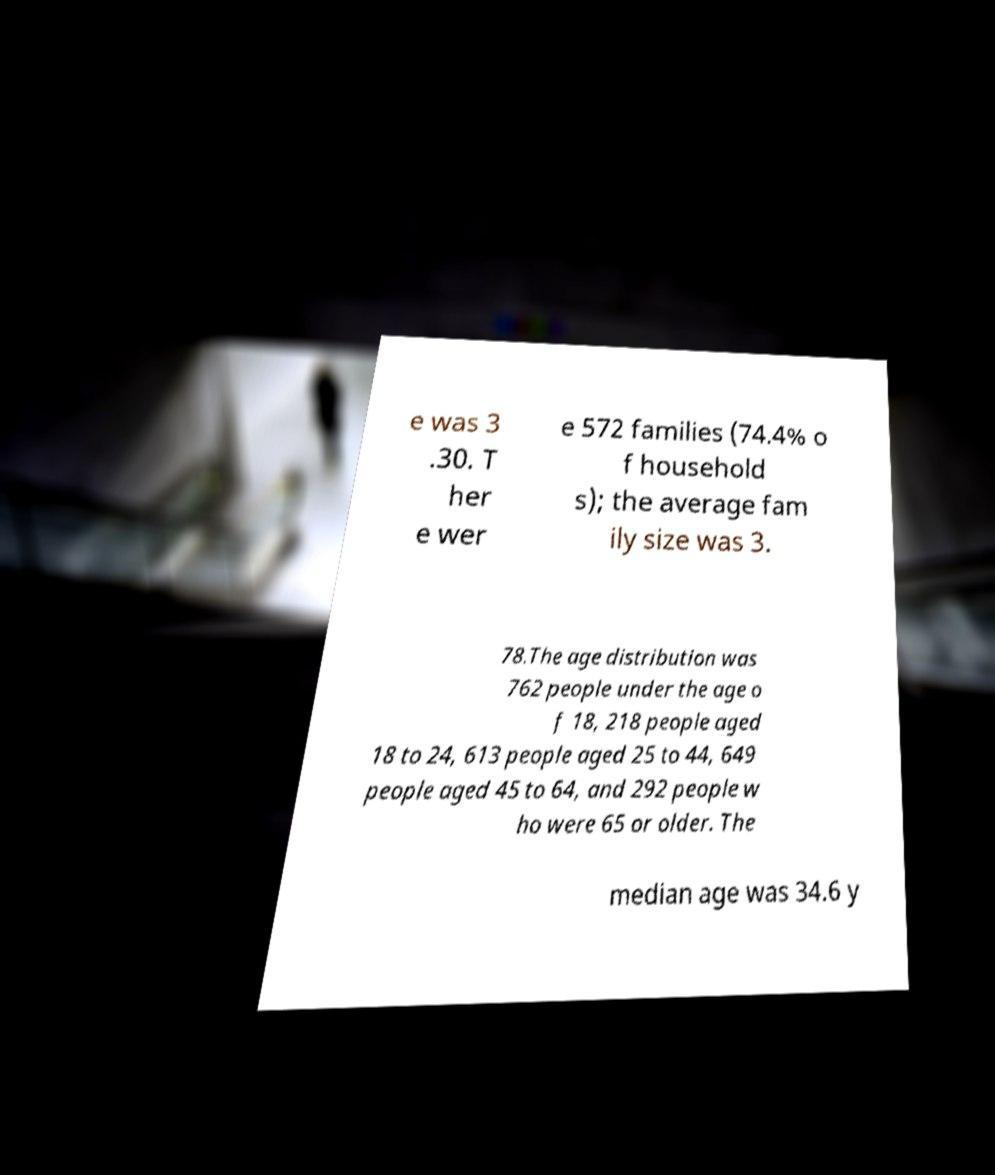Could you assist in decoding the text presented in this image and type it out clearly? e was 3 .30. T her e wer e 572 families (74.4% o f household s); the average fam ily size was 3. 78.The age distribution was 762 people under the age o f 18, 218 people aged 18 to 24, 613 people aged 25 to 44, 649 people aged 45 to 64, and 292 people w ho were 65 or older. The median age was 34.6 y 